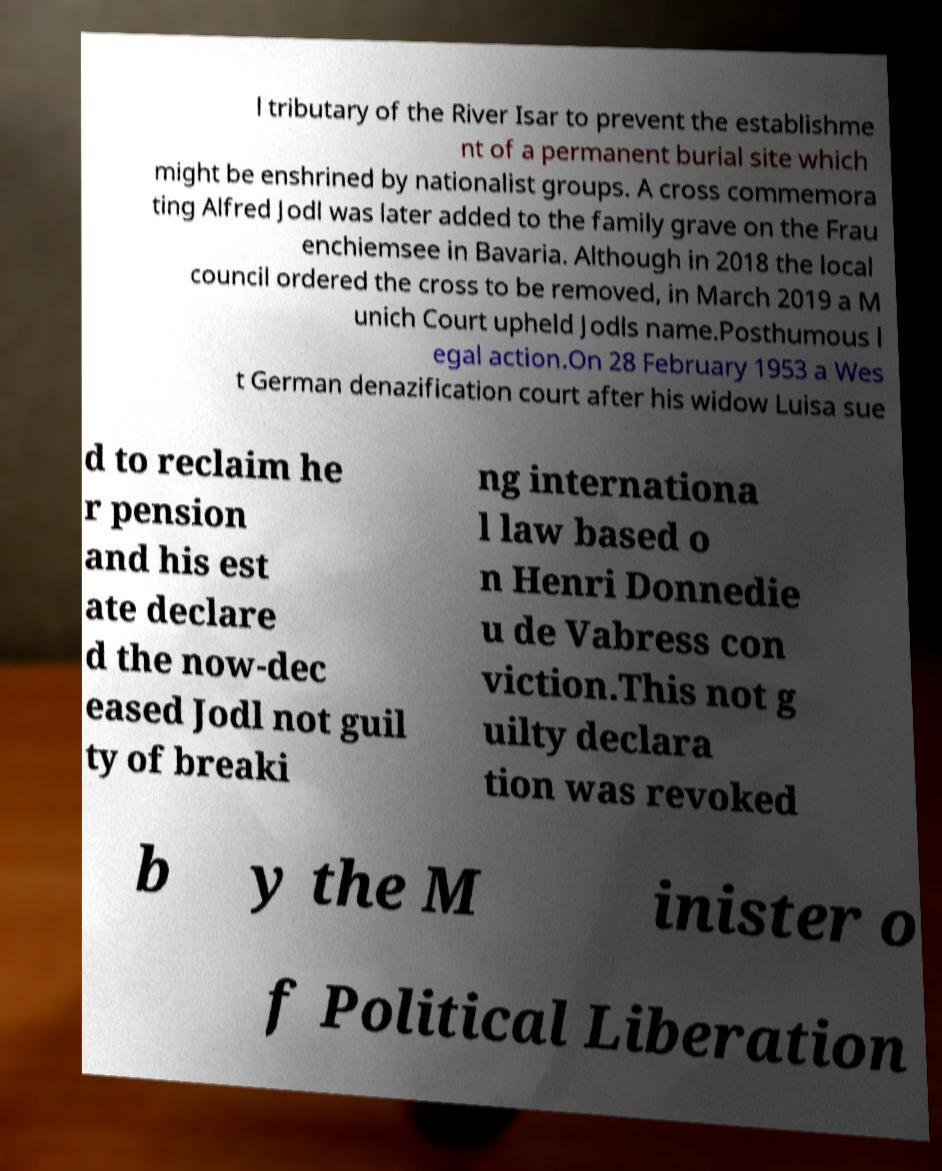I need the written content from this picture converted into text. Can you do that? l tributary of the River Isar to prevent the establishme nt of a permanent burial site which might be enshrined by nationalist groups. A cross commemora ting Alfred Jodl was later added to the family grave on the Frau enchiemsee in Bavaria. Although in 2018 the local council ordered the cross to be removed, in March 2019 a M unich Court upheld Jodls name.Posthumous l egal action.On 28 February 1953 a Wes t German denazification court after his widow Luisa sue d to reclaim he r pension and his est ate declare d the now-dec eased Jodl not guil ty of breaki ng internationa l law based o n Henri Donnedie u de Vabress con viction.This not g uilty declara tion was revoked b y the M inister o f Political Liberation 